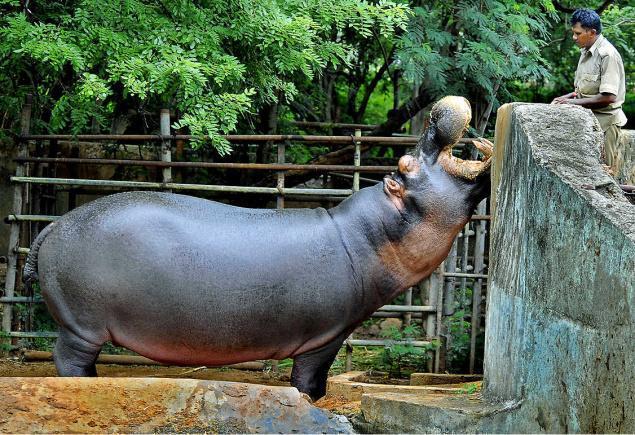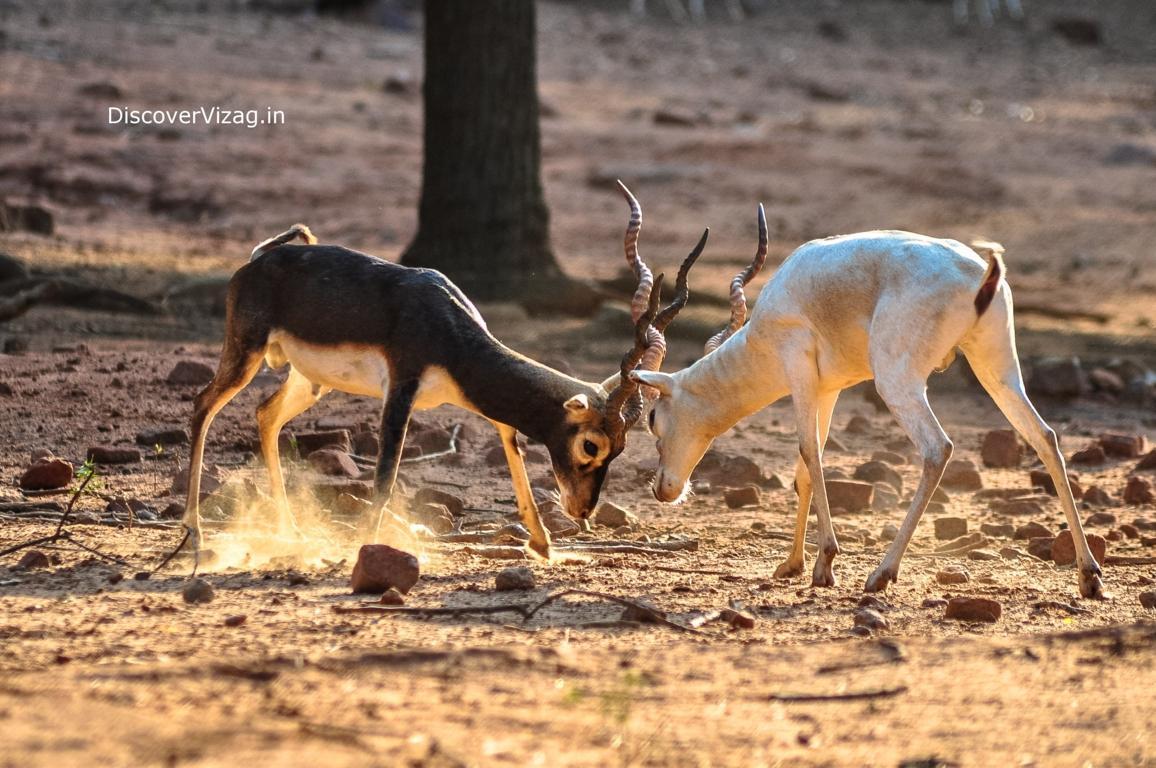The first image is the image on the left, the second image is the image on the right. Considering the images on both sides, is "The animals in one of the images have horns." valid? Answer yes or no. Yes. 